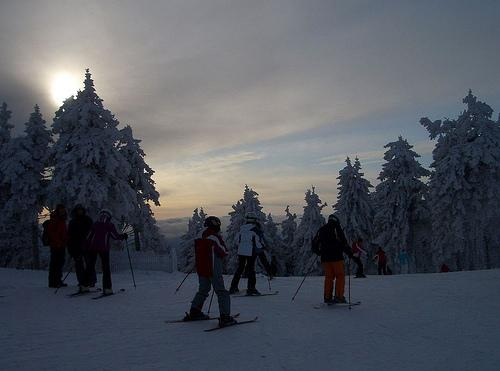What is touching the snow?

Choices:
A) cats paw
B) skis
C) dogs paw
D) cowboy boots skis 